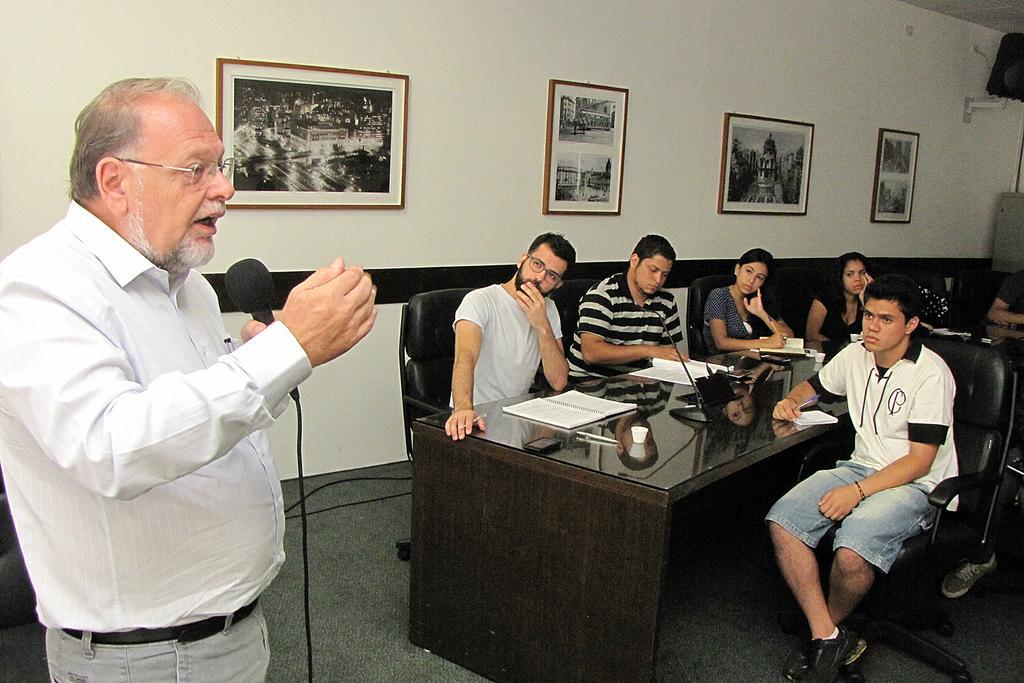Describe this image in one or two sentences. As we can see in the image, there are few people sitting around table on chairs and the man who is standing on the left is talking on mike and on wall there are four photo frames. 